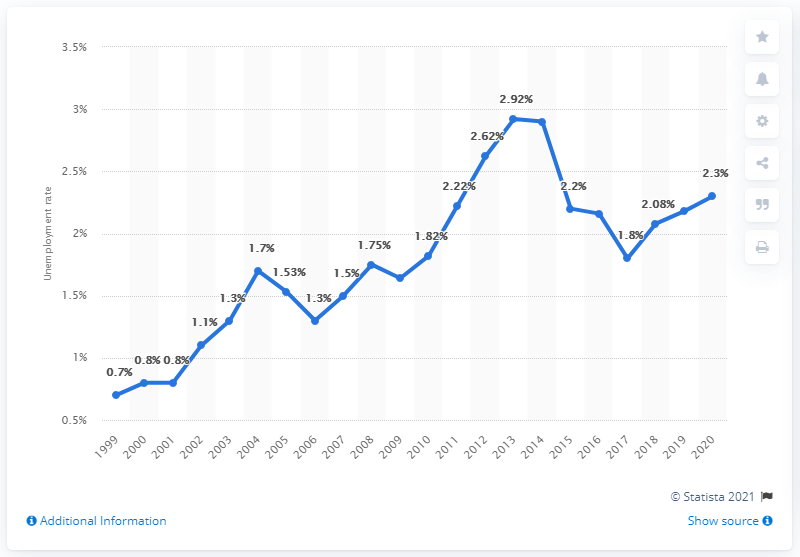Draw attention to some important aspects in this diagram. In 2020, Kuwait's unemployment rate was 2.3%. 